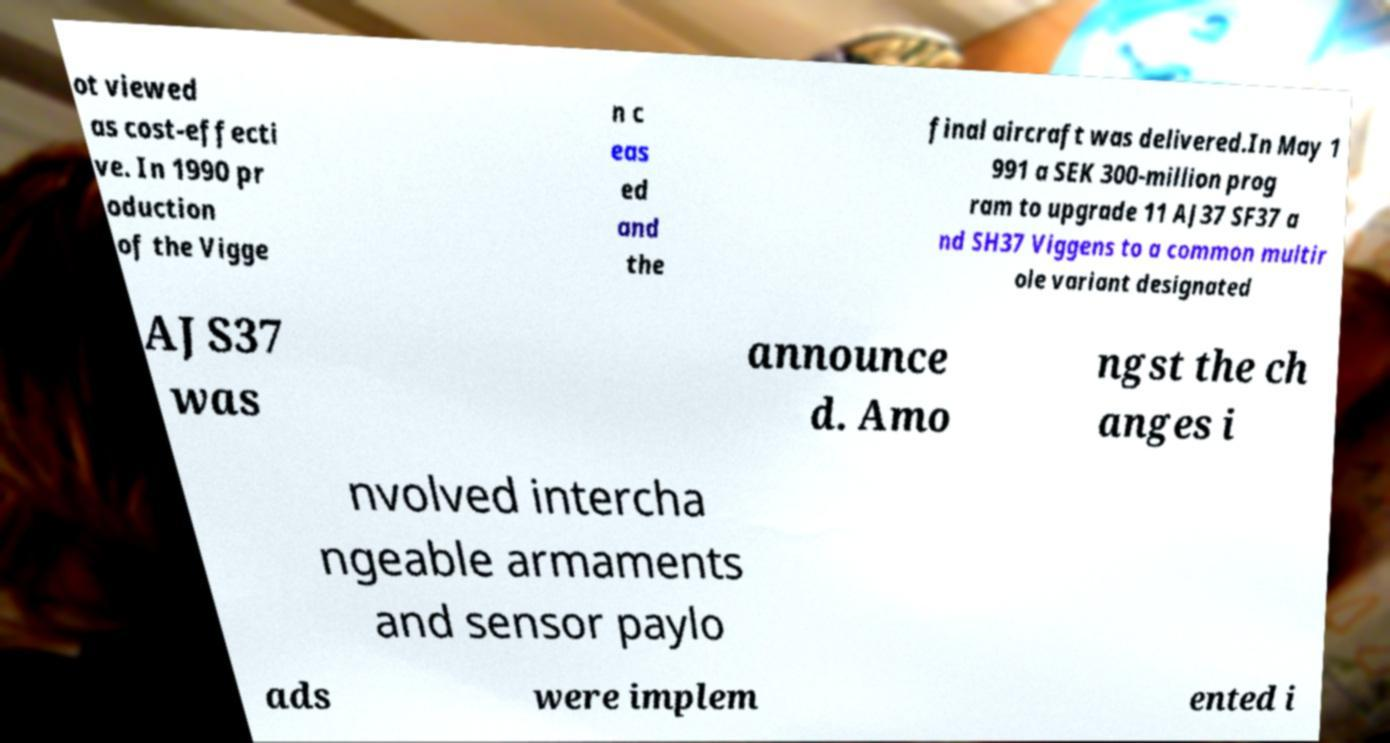Could you extract and type out the text from this image? ot viewed as cost-effecti ve. In 1990 pr oduction of the Vigge n c eas ed and the final aircraft was delivered.In May 1 991 a SEK 300-million prog ram to upgrade 11 AJ37 SF37 a nd SH37 Viggens to a common multir ole variant designated AJS37 was announce d. Amo ngst the ch anges i nvolved intercha ngeable armaments and sensor paylo ads were implem ented i 